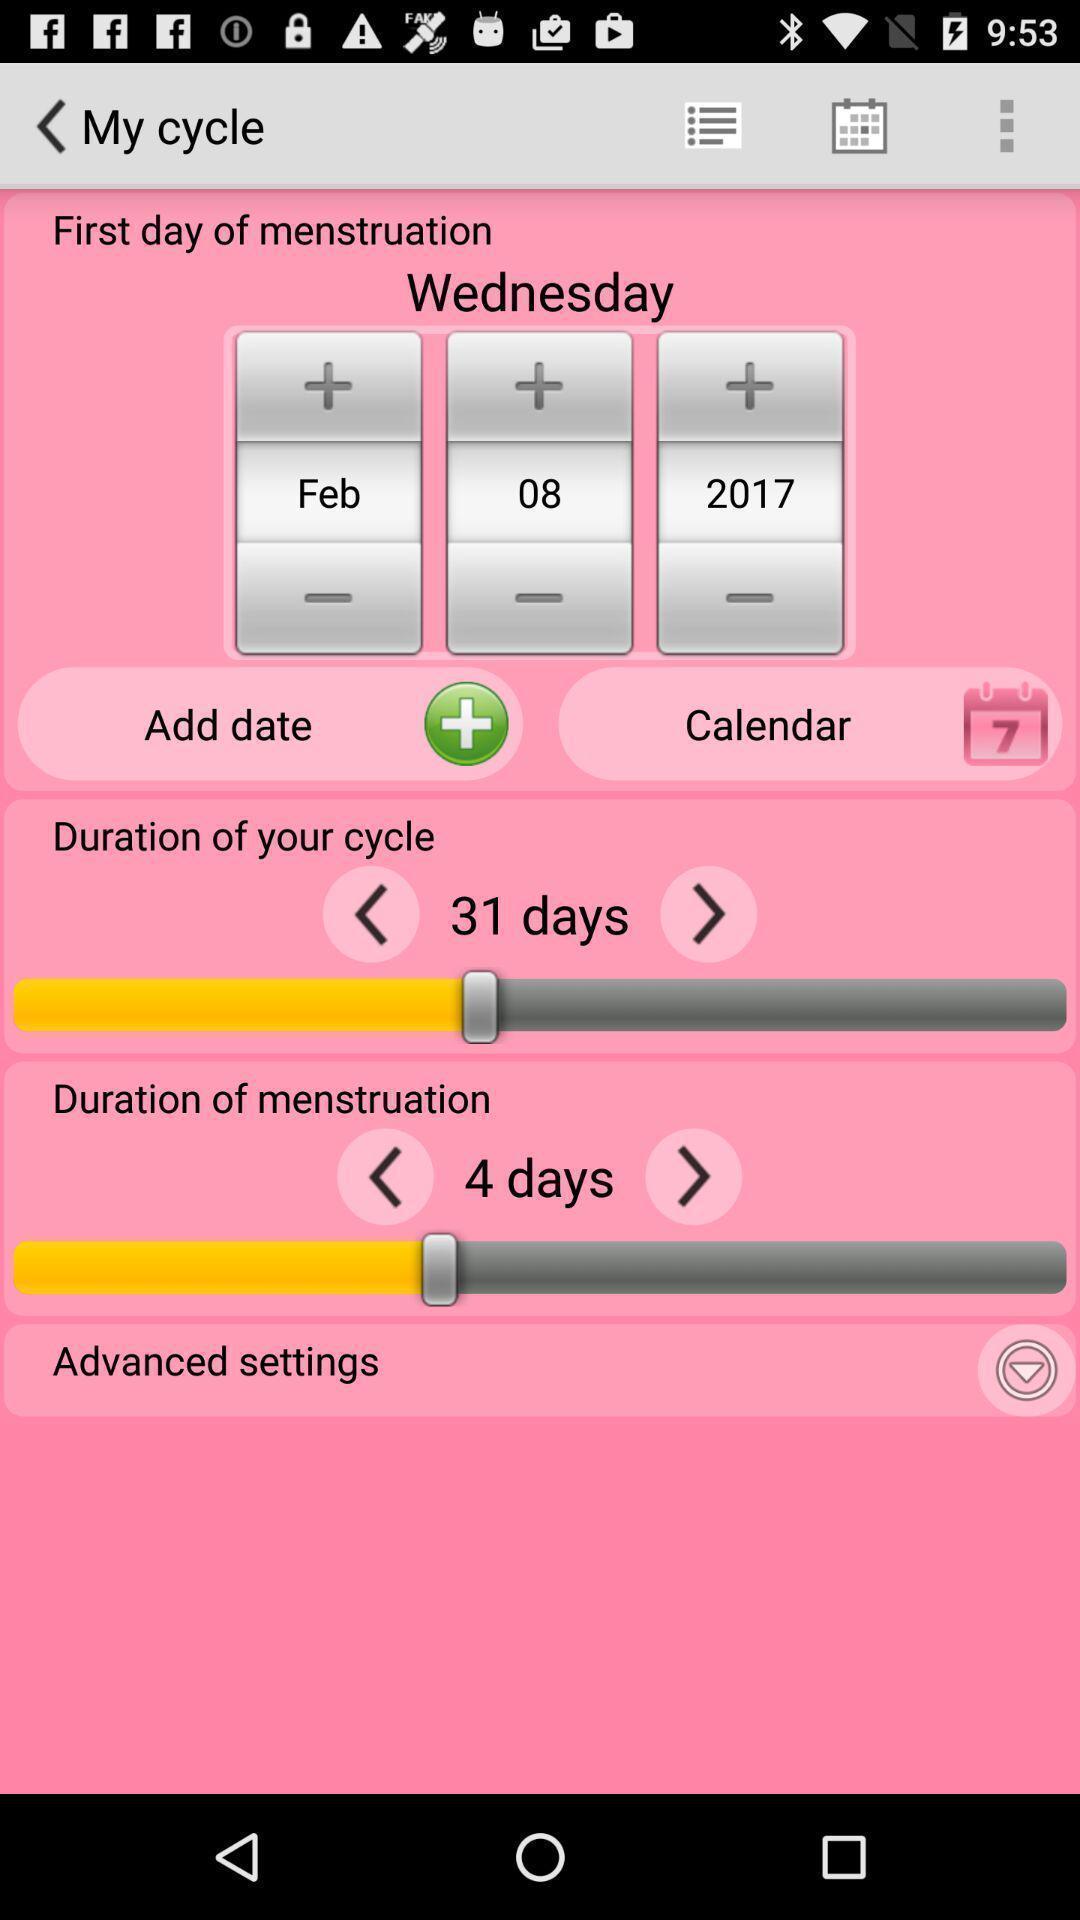Provide a detailed account of this screenshot. Page with cycle details in a period tracker app. 